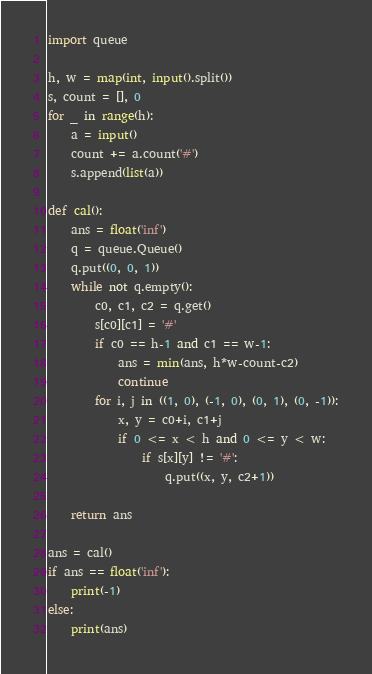Convert code to text. <code><loc_0><loc_0><loc_500><loc_500><_Python_>import queue

h, w = map(int, input().split())
s, count = [], 0
for _ in range(h):
    a = input()
    count += a.count('#')
    s.append(list(a))

def cal():
    ans = float('inf')
    q = queue.Queue()
    q.put((0, 0, 1))
    while not q.empty():
        c0, c1, c2 = q.get()
        s[c0][c1] = '#'
        if c0 == h-1 and c1 == w-1:
            ans = min(ans, h*w-count-c2)
            continue
        for i, j in ((1, 0), (-1, 0), (0, 1), (0, -1)):
            x, y = c0+i, c1+j
            if 0 <= x < h and 0 <= y < w:
                if s[x][y] != '#':
                    q.put((x, y, c2+1))

    return ans

ans = cal()
if ans == float('inf'):
    print(-1)
else:
    print(ans)
</code> 